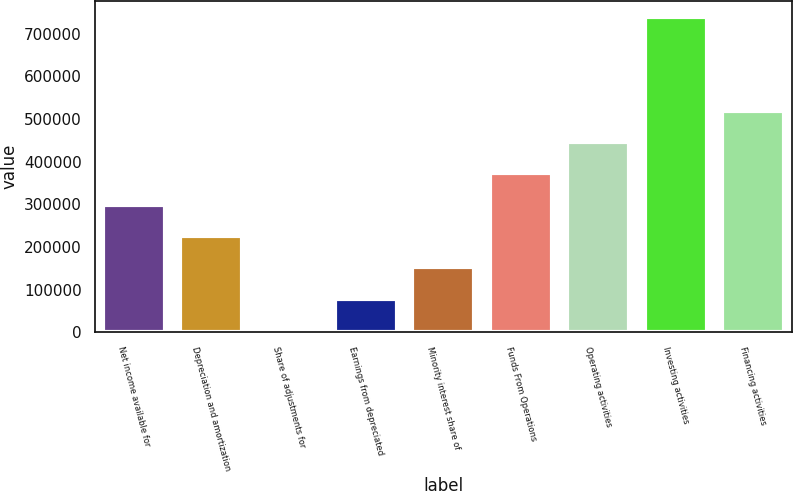<chart> <loc_0><loc_0><loc_500><loc_500><bar_chart><fcel>Net income available for<fcel>Depreciation and amortization<fcel>Share of adjustments for<fcel>Earnings from depreciated<fcel>Minority interest share of<fcel>Funds From Operations<fcel>Operating activities<fcel>Investing activities<fcel>Financing activities<nl><fcel>299268<fcel>225768<fcel>5268<fcel>78768.1<fcel>152268<fcel>372768<fcel>446269<fcel>740269<fcel>519769<nl></chart> 